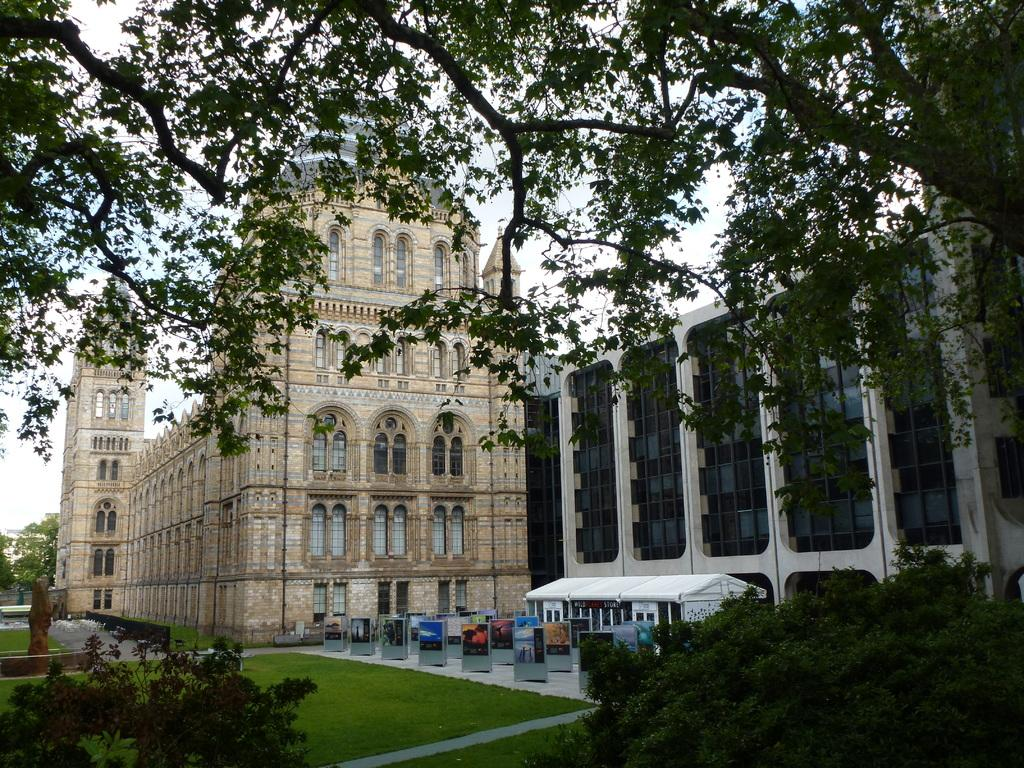What type of structures can be seen in the image? There are buildings and a shed in the image. Are there any signs or messages visible in the image? Yes, there are advertisements in the image. What type of vegetation is present in the image? There are trees and grass in the image. What part of the buildings can be seen in the image? There are windows in the image. What is visible in the background of the image? The sky is visible in the image. What type of toys can be seen floating in the water in the image? There are no toys or water present in the image; it features buildings, a shed, advertisements, trees, grass, windows, and the sky. 